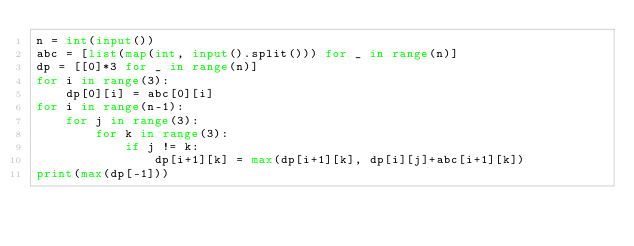<code> <loc_0><loc_0><loc_500><loc_500><_Python_>n = int(input())
abc = [list(map(int, input().split())) for _ in range(n)]
dp = [[0]*3 for _ in range(n)]
for i in range(3):
    dp[0][i] = abc[0][i]
for i in range(n-1):
    for j in range(3):
        for k in range(3):
            if j != k:
                dp[i+1][k] = max(dp[i+1][k], dp[i][j]+abc[i+1][k])
print(max(dp[-1]))
</code> 